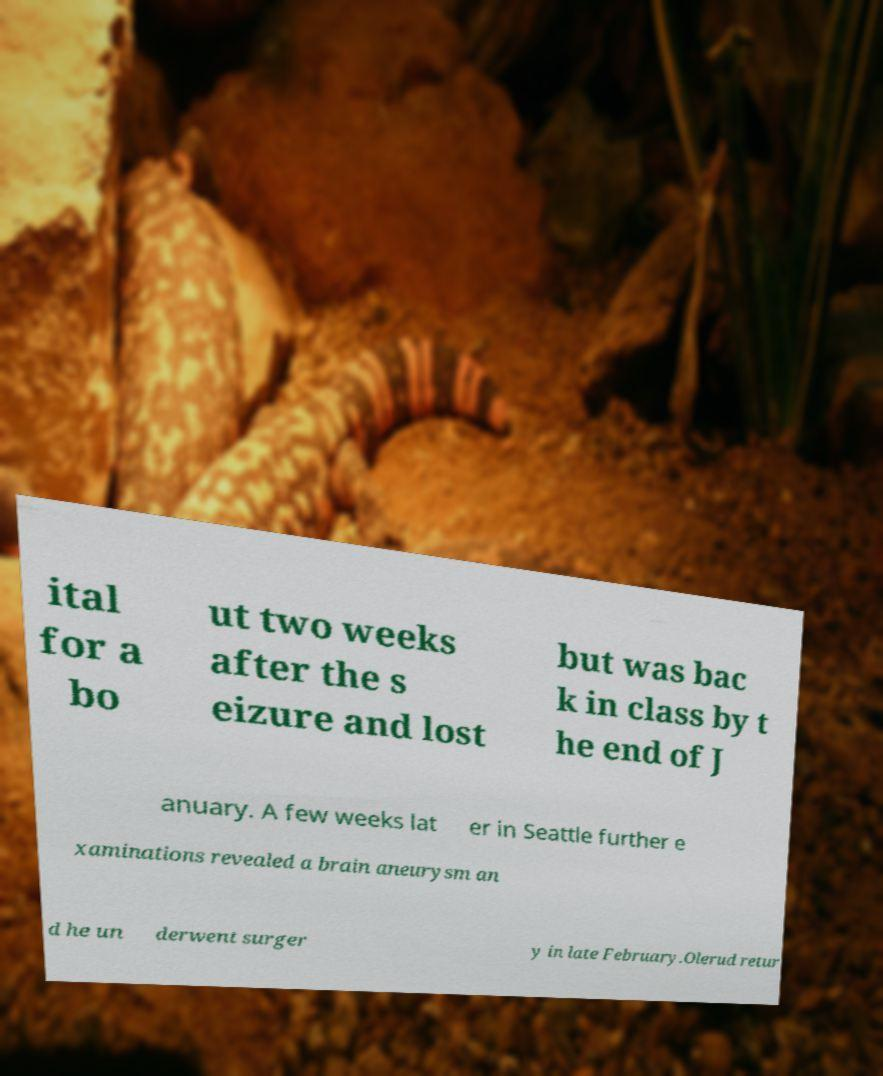Can you read and provide the text displayed in the image?This photo seems to have some interesting text. Can you extract and type it out for me? ital for a bo ut two weeks after the s eizure and lost but was bac k in class by t he end of J anuary. A few weeks lat er in Seattle further e xaminations revealed a brain aneurysm an d he un derwent surger y in late February.Olerud retur 